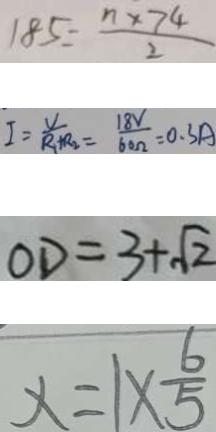Convert formula to latex. <formula><loc_0><loc_0><loc_500><loc_500>1 8 5 = \frac { n \times 7 4 } { 2 } 
 I = \frac { V } { R _ { 1 } + R _ { 2 } } = \frac { 1 8 V } { 6 0 \Omega } = 0 . 3 A 
 O D = 3 + \sqrt { 2 } 
 x = 1 \times \frac { 6 } { 5 }</formula> 